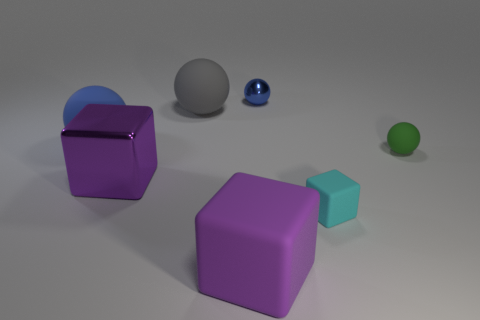How many objects are visible in the image? There are five objects visible in the image: two purple cubes, one blue matte ball, and two smaller balls - one blue and one green. 